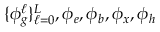<formula> <loc_0><loc_0><loc_500><loc_500>\{ \phi _ { g } ^ { \ell } \} _ { \ell = 0 } ^ { L } , \phi _ { e } , \phi _ { b } , \phi _ { x } , \phi _ { h }</formula> 